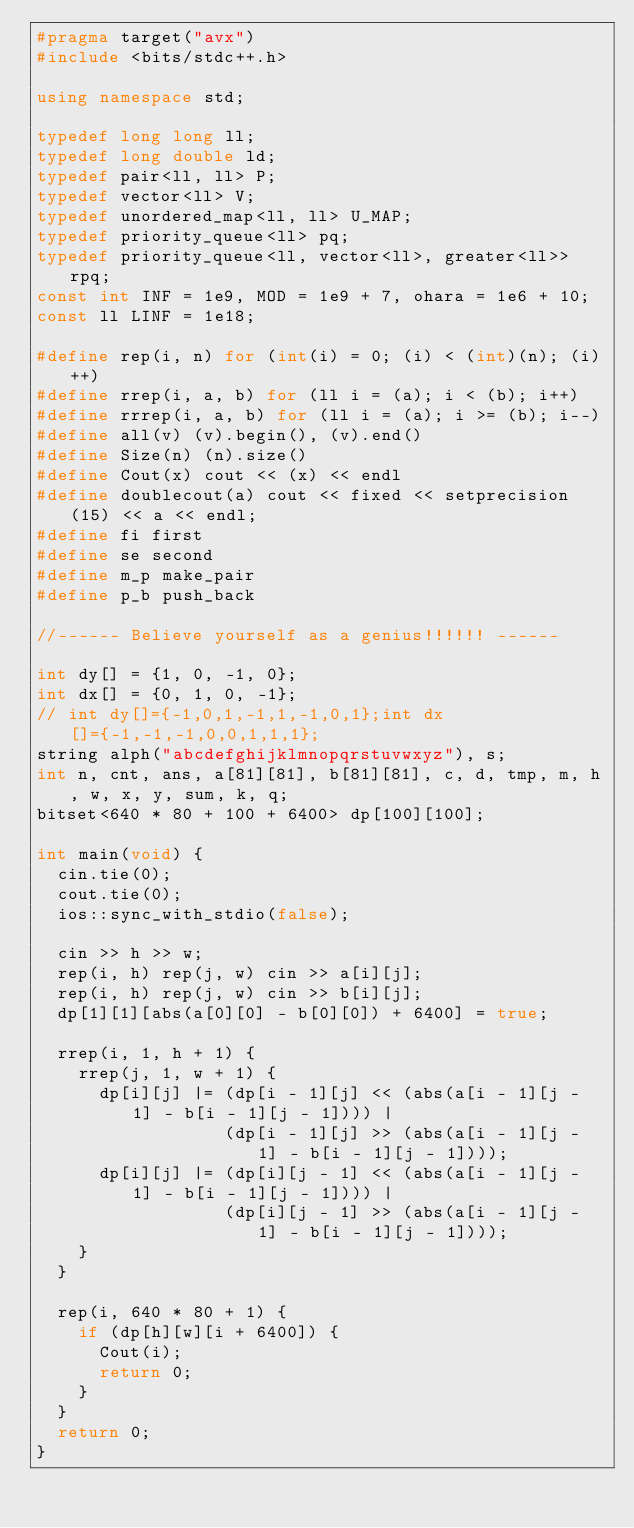Convert code to text. <code><loc_0><loc_0><loc_500><loc_500><_C++_>#pragma target("avx")
#include <bits/stdc++.h>

using namespace std;

typedef long long ll;
typedef long double ld;
typedef pair<ll, ll> P;
typedef vector<ll> V;
typedef unordered_map<ll, ll> U_MAP;
typedef priority_queue<ll> pq;
typedef priority_queue<ll, vector<ll>, greater<ll>> rpq;
const int INF = 1e9, MOD = 1e9 + 7, ohara = 1e6 + 10;
const ll LINF = 1e18;

#define rep(i, n) for (int(i) = 0; (i) < (int)(n); (i)++)
#define rrep(i, a, b) for (ll i = (a); i < (b); i++)
#define rrrep(i, a, b) for (ll i = (a); i >= (b); i--)
#define all(v) (v).begin(), (v).end()
#define Size(n) (n).size()
#define Cout(x) cout << (x) << endl
#define doublecout(a) cout << fixed << setprecision(15) << a << endl;
#define fi first
#define se second
#define m_p make_pair
#define p_b push_back

//------ Believe yourself as a genius!!!!!! ------

int dy[] = {1, 0, -1, 0};
int dx[] = {0, 1, 0, -1};
// int dy[]={-1,0,1,-1,1,-1,0,1};int dx[]={-1,-1,-1,0,0,1,1,1};
string alph("abcdefghijklmnopqrstuvwxyz"), s;
int n, cnt, ans, a[81][81], b[81][81], c, d, tmp, m, h, w, x, y, sum, k, q;
bitset<640 * 80 + 100 + 6400> dp[100][100];

int main(void) {
  cin.tie(0);
  cout.tie(0);
  ios::sync_with_stdio(false);

  cin >> h >> w;
  rep(i, h) rep(j, w) cin >> a[i][j];
  rep(i, h) rep(j, w) cin >> b[i][j];
  dp[1][1][abs(a[0][0] - b[0][0]) + 6400] = true;

  rrep(i, 1, h + 1) {
    rrep(j, 1, w + 1) {
      dp[i][j] |= (dp[i - 1][j] << (abs(a[i - 1][j - 1] - b[i - 1][j - 1]))) |
                  (dp[i - 1][j] >> (abs(a[i - 1][j - 1] - b[i - 1][j - 1])));
      dp[i][j] |= (dp[i][j - 1] << (abs(a[i - 1][j - 1] - b[i - 1][j - 1]))) |
                  (dp[i][j - 1] >> (abs(a[i - 1][j - 1] - b[i - 1][j - 1])));
    }
  }

  rep(i, 640 * 80 + 1) {
    if (dp[h][w][i + 6400]) {
      Cout(i);
      return 0;
    }
  }
  return 0;
}
</code> 